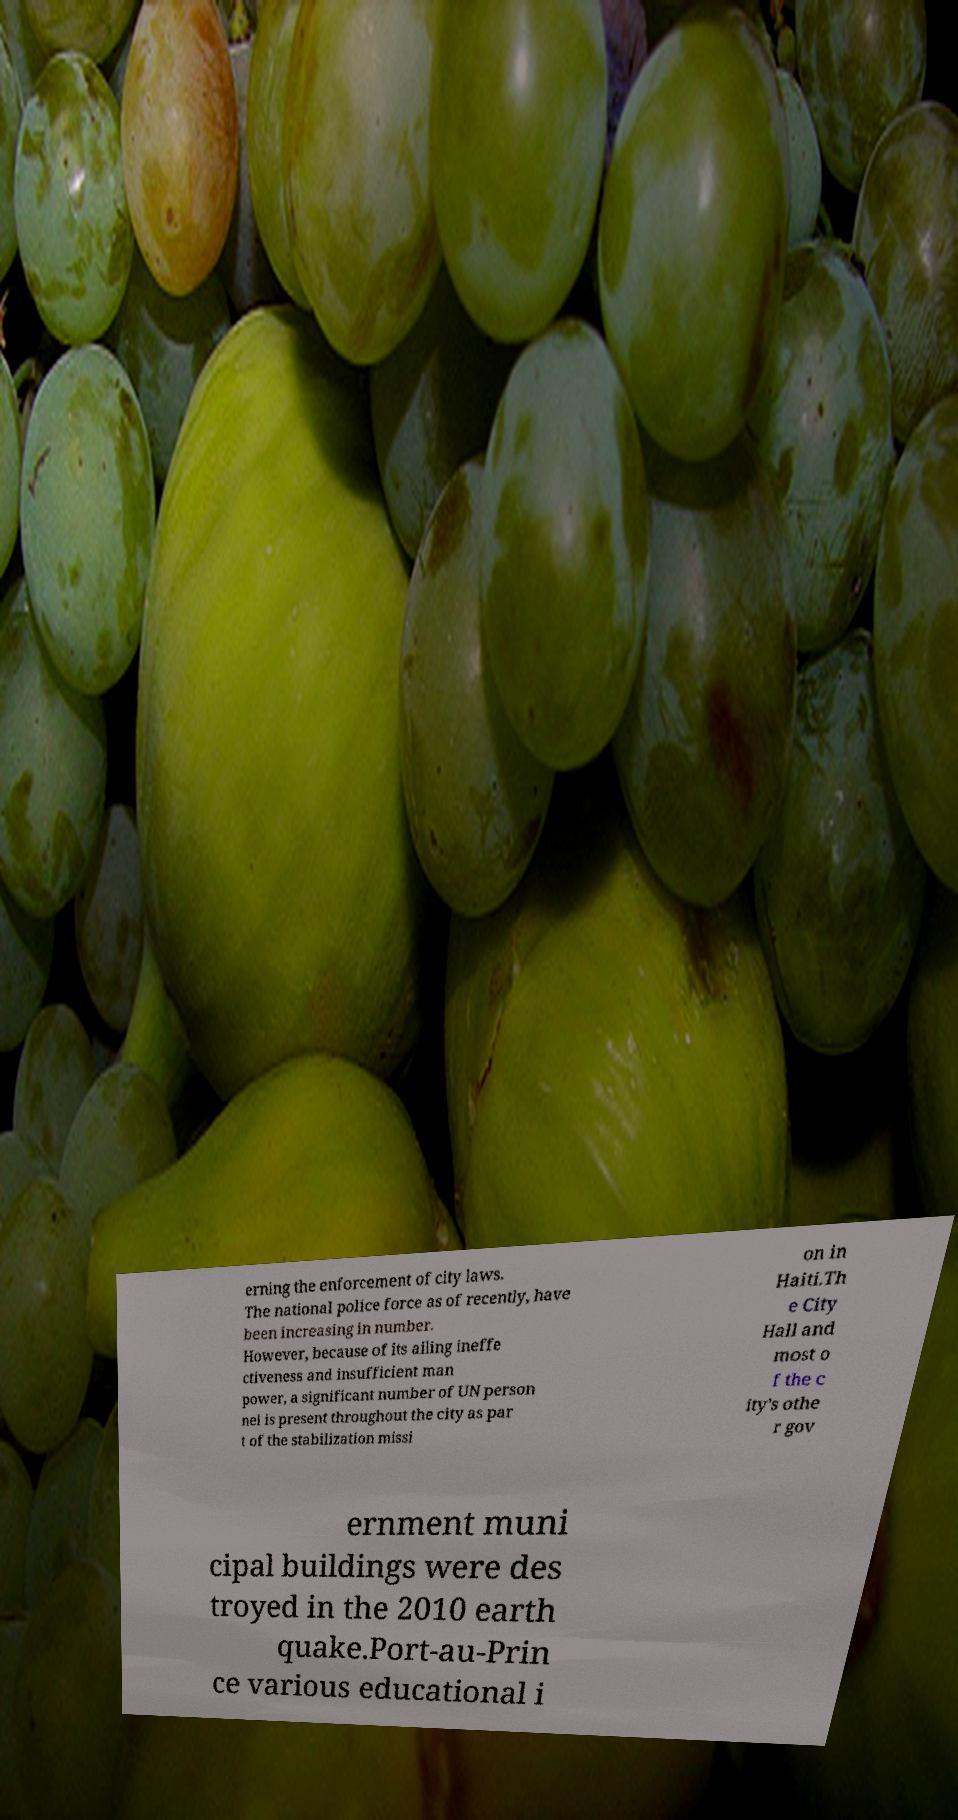What messages or text are displayed in this image? I need them in a readable, typed format. erning the enforcement of city laws. The national police force as of recently, have been increasing in number. However, because of its ailing ineffe ctiveness and insufficient man power, a significant number of UN person nel is present throughout the city as par t of the stabilization missi on in Haiti.Th e City Hall and most o f the c ity's othe r gov ernment muni cipal buildings were des troyed in the 2010 earth quake.Port-au-Prin ce various educational i 